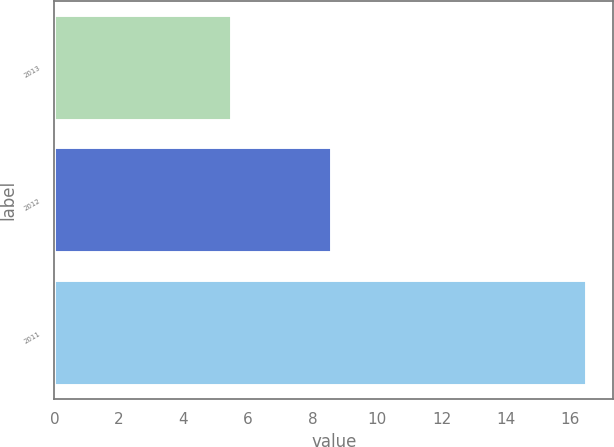<chart> <loc_0><loc_0><loc_500><loc_500><bar_chart><fcel>2013<fcel>2012<fcel>2011<nl><fcel>5.5<fcel>8.6<fcel>16.5<nl></chart> 